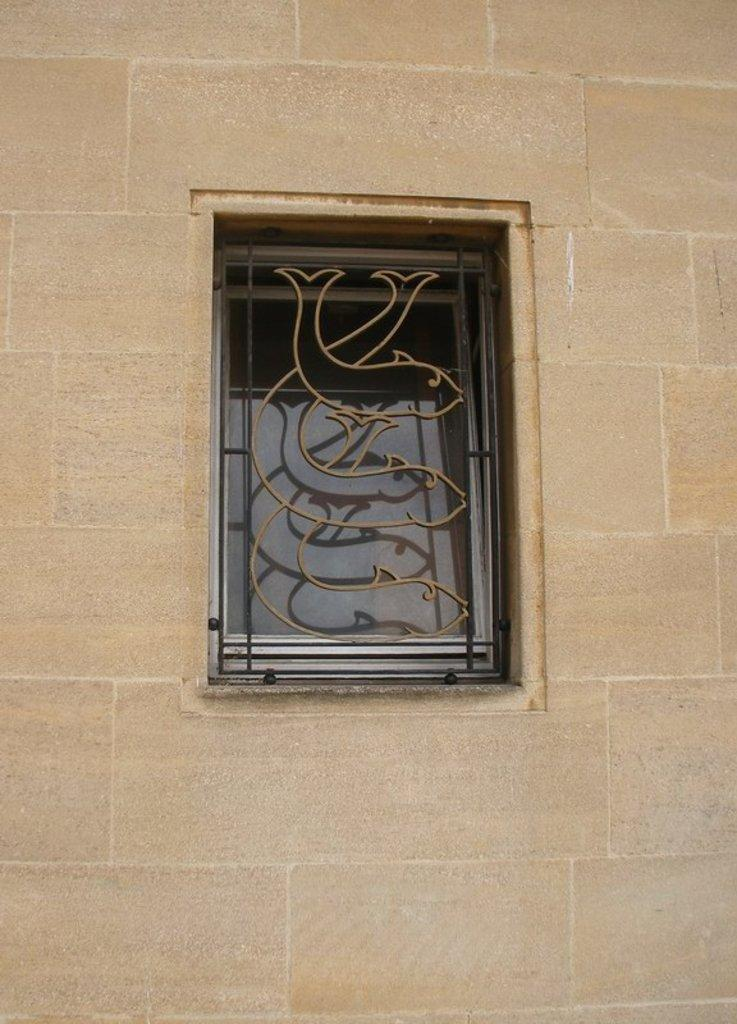What is present on the wall in the image? There is a window in the center of the wall. What is the color of the wall in the image? The wall is of cream color. What invention can be seen in the image? There is no invention present in the image; it only features a wall with a window. What is the name of the son of the person who created the wall in the image? There is no information about the creator of the wall or their son in the image. 